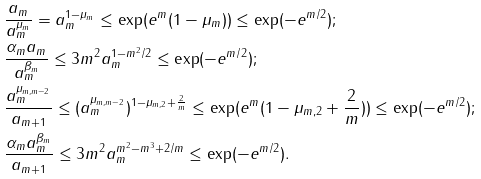Convert formula to latex. <formula><loc_0><loc_0><loc_500><loc_500>& \frac { a _ { m } } { a _ { m } ^ { \mu _ { m } } } = a _ { m } ^ { 1 - \mu _ { m } } \leq \exp ( e ^ { m } ( 1 - \mu _ { m } ) ) \leq \exp ( - e ^ { m / 2 } ) ; \\ & \frac { \alpha _ { m } a _ { m } } { a _ { m } ^ { \beta _ { m } } } \leq 3 m ^ { 2 } a _ { m } ^ { 1 - m ^ { 2 } / 2 } \leq \exp ( - e ^ { m / 2 } ) ; \\ & \frac { a _ { m } ^ { \mu _ { m , m - 2 } } } { a _ { m + 1 } } \leq ( a _ { m } ^ { \mu _ { m , m - 2 } } ) ^ { 1 - \mu _ { m , 2 } + \frac { 2 } { m } } \leq \exp ( e ^ { m } ( 1 - \mu _ { m , 2 } + \frac { 2 } { m } ) ) \leq \exp ( - e ^ { m / 2 } ) ; \\ & \frac { \alpha _ { m } a _ { m } ^ { \beta _ { m } } } { a _ { m + 1 } } \leq 3 m ^ { 2 } a _ { m } ^ { m ^ { 2 } - m ^ { 3 } + 2 / m } \leq \exp ( - e ^ { m / 2 } ) .</formula> 